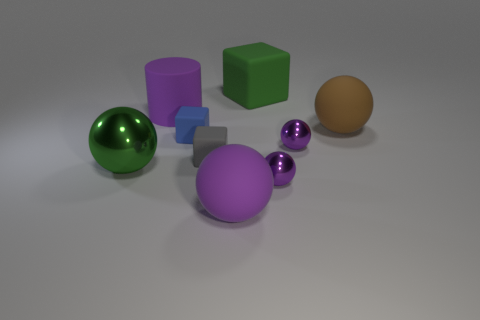What is the material of the large thing that is the same color as the large block?
Provide a short and direct response. Metal. There is a metal object that is to the left of the large purple ball; does it have the same shape as the tiny metal object in front of the large shiny thing?
Offer a terse response. Yes. There is another block that is the same size as the gray rubber cube; what is it made of?
Keep it short and to the point. Rubber. Does the large green object that is behind the blue matte object have the same material as the small purple thing that is behind the big shiny sphere?
Make the answer very short. No. There is a blue rubber object that is the same size as the gray rubber block; what shape is it?
Give a very brief answer. Cube. How many other things are the same color as the big cylinder?
Keep it short and to the point. 3. There is a matte thing on the right side of the green matte thing; what is its color?
Provide a succinct answer. Brown. How many other things are there of the same material as the large brown thing?
Provide a short and direct response. 5. Are there more large spheres behind the large green metallic thing than small matte things to the right of the tiny gray rubber thing?
Your answer should be compact. Yes. There is a brown rubber object; how many small matte things are behind it?
Your answer should be very brief. 0. 